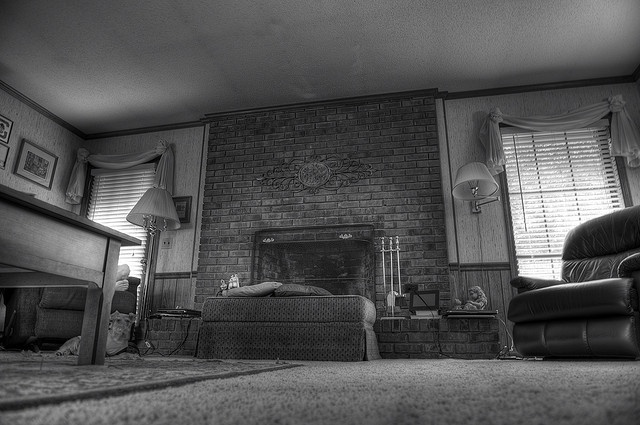Describe the objects in this image and their specific colors. I can see chair in black, gray, darkgray, and lightgray tones, couch in black, gray, darkgray, and gainsboro tones, dining table in black and gray tones, couch in black and gray tones, and couch in black, gray, darkgray, and lightgray tones in this image. 